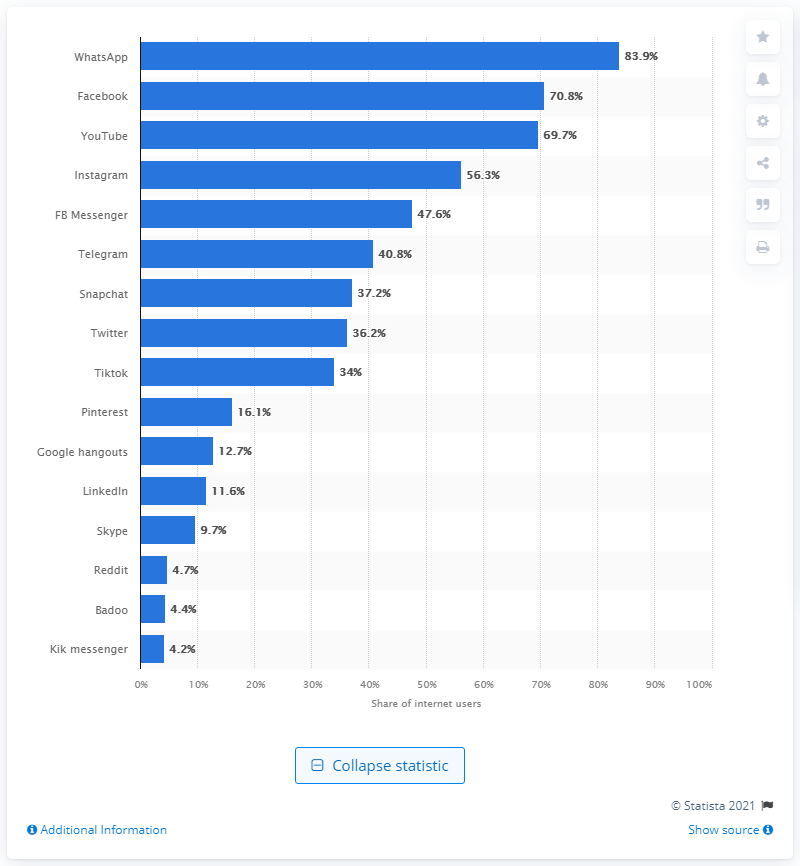Draw attention to some important aspects in this diagram. According to the latest data, WhatsApp was the most popular social media platform in Ghana during the third quarter of 2020. About 70.8% of internet users in Ghana used Facebook in 2020. In Ghana, YouTube accounts for 69.7% of the country's internet usage. 